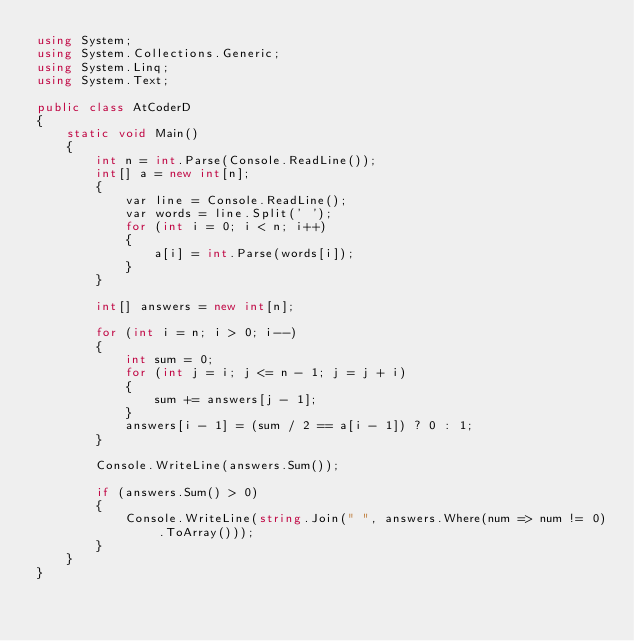<code> <loc_0><loc_0><loc_500><loc_500><_C#_>using System;
using System.Collections.Generic;
using System.Linq;
using System.Text;

public class AtCoderD
{
    static void Main()
    {
        int n = int.Parse(Console.ReadLine());
        int[] a = new int[n];
        {
            var line = Console.ReadLine();
            var words = line.Split(' ');
            for (int i = 0; i < n; i++)
            {
                a[i] = int.Parse(words[i]);
            }
        }

        int[] answers = new int[n];

        for (int i = n; i > 0; i--)
        {
            int sum = 0;
            for (int j = i; j <= n - 1; j = j + i)
            {
                sum += answers[j - 1];
            }
            answers[i - 1] = (sum / 2 == a[i - 1]) ? 0 : 1;
        }

        Console.WriteLine(answers.Sum());

        if (answers.Sum() > 0)
        {
            Console.WriteLine(string.Join(" ", answers.Where(num => num != 0).ToArray()));
        }
    }
}</code> 